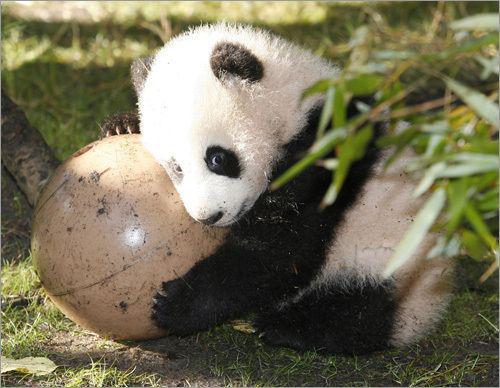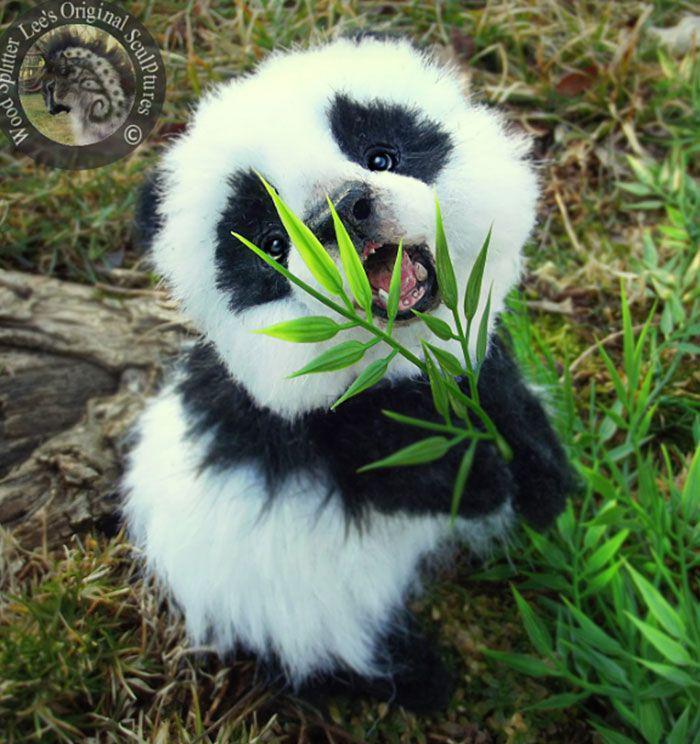The first image is the image on the left, the second image is the image on the right. For the images shown, is this caption "A panda has both front paws wrapped around something that is more round than stick-shaped." true? Answer yes or no. Yes. The first image is the image on the left, the second image is the image on the right. Examine the images to the left and right. Is the description "There is a single panda sitting in the grass in the image on the left." accurate? Answer yes or no. Yes. 